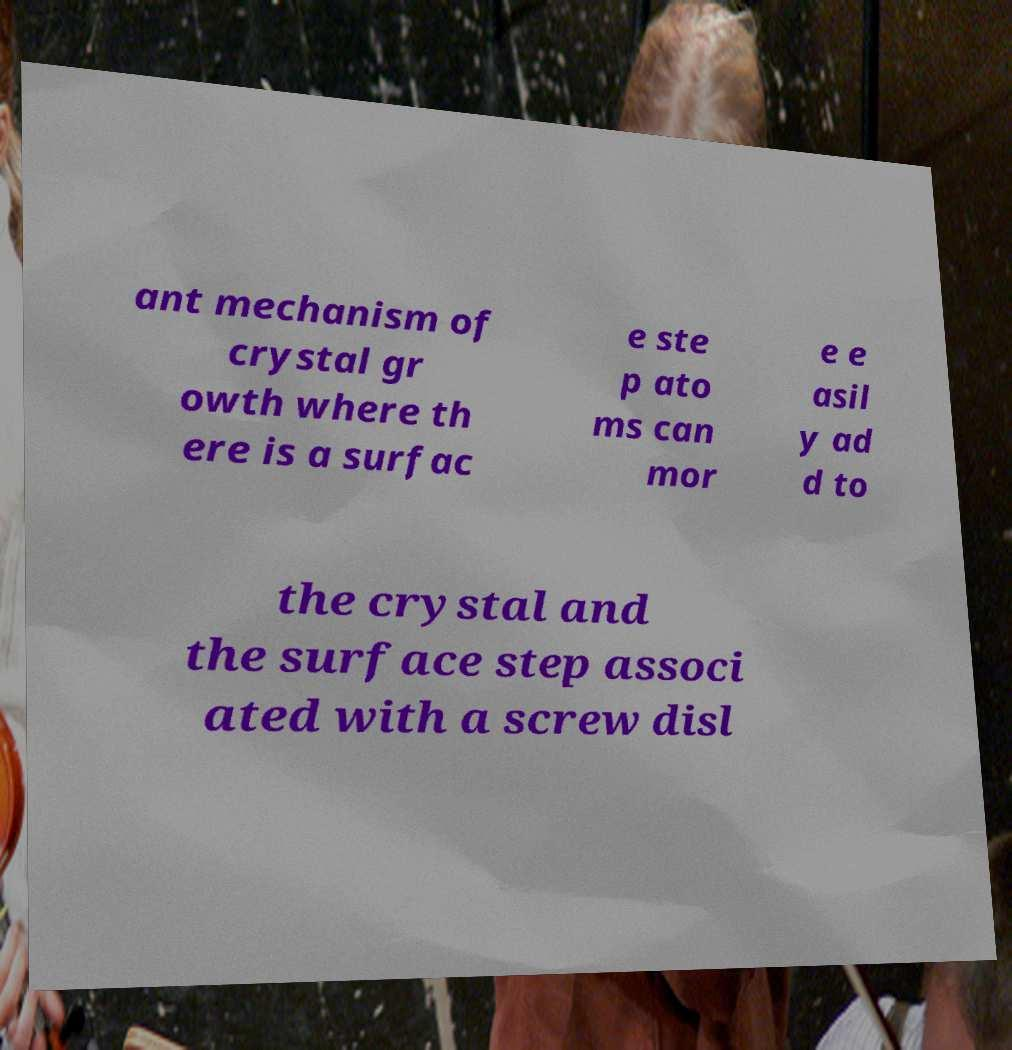For documentation purposes, I need the text within this image transcribed. Could you provide that? ant mechanism of crystal gr owth where th ere is a surfac e ste p ato ms can mor e e asil y ad d to the crystal and the surface step associ ated with a screw disl 